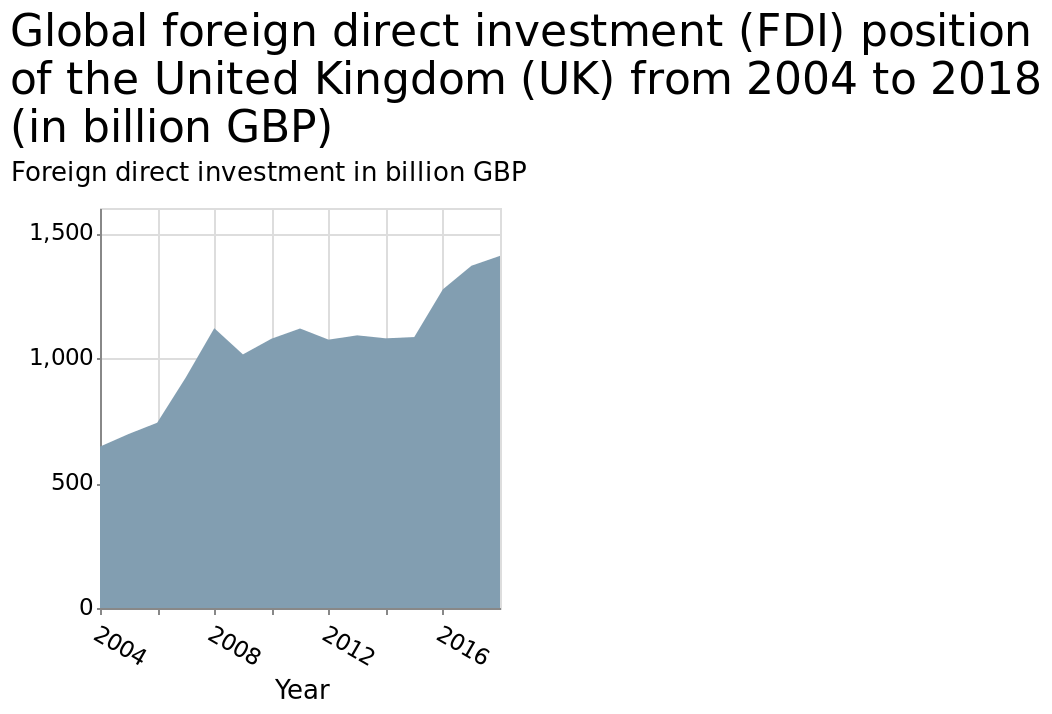<image>
How many peaks were observed in investments between 2010 and 2015?  Only one peak was observed in investments between 2010 and 2015. What is the name of the area diagram? The area diagram is called Global foreign direct investment (FDI) position of the United Kingdom (UK) from 2004 to 2018. please summary the statistics and relations of the chart The chart shows an increase in investment trend between 2004 and 2018. In 2004, investment stood at circa £600 billion, rising steadily to 2008, when investment stood at approximately £1,100 billion.  2009 saw a reduction to 1,000 billion, with a steady state from 2010 to 2015, holding at just over 1,000 billion. Between 2015 and 2018, investment increased to 1,400 billion. 